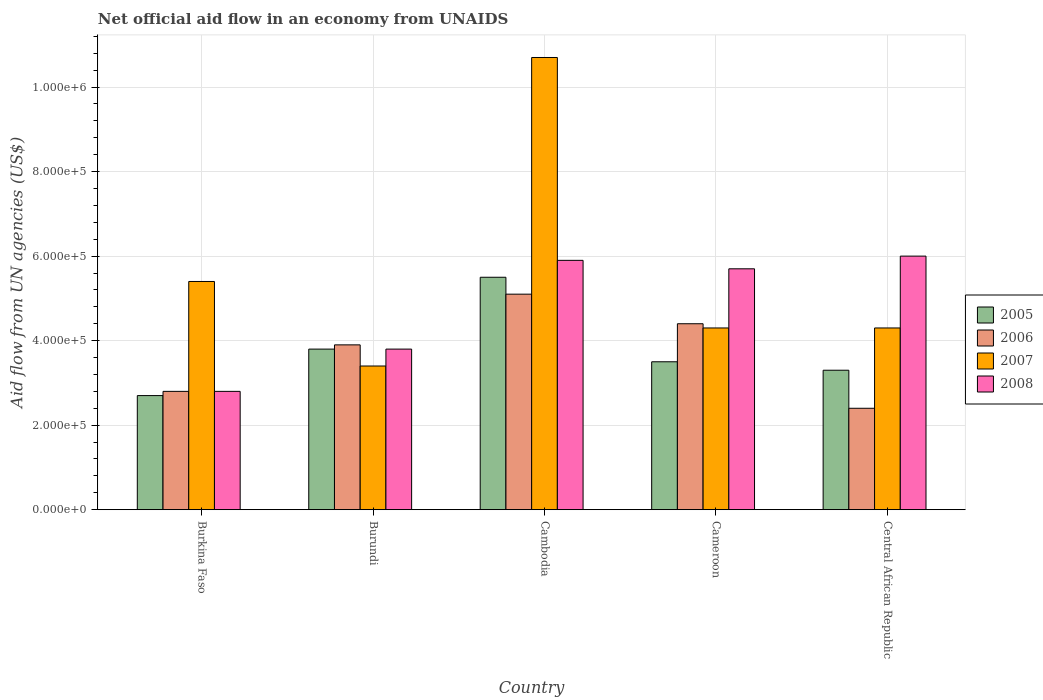How many different coloured bars are there?
Keep it short and to the point. 4. How many bars are there on the 1st tick from the left?
Offer a terse response. 4. What is the label of the 3rd group of bars from the left?
Offer a very short reply. Cambodia. In how many cases, is the number of bars for a given country not equal to the number of legend labels?
Your answer should be very brief. 0. What is the net official aid flow in 2008 in Cambodia?
Make the answer very short. 5.90e+05. Across all countries, what is the maximum net official aid flow in 2007?
Provide a succinct answer. 1.07e+06. Across all countries, what is the minimum net official aid flow in 2008?
Provide a short and direct response. 2.80e+05. In which country was the net official aid flow in 2005 maximum?
Offer a terse response. Cambodia. In which country was the net official aid flow in 2006 minimum?
Ensure brevity in your answer.  Central African Republic. What is the total net official aid flow in 2007 in the graph?
Provide a succinct answer. 2.81e+06. What is the difference between the net official aid flow in 2006 in Cameroon and the net official aid flow in 2005 in Cambodia?
Offer a terse response. -1.10e+05. What is the average net official aid flow in 2006 per country?
Provide a short and direct response. 3.72e+05. What is the ratio of the net official aid flow in 2008 in Cameroon to that in Central African Republic?
Keep it short and to the point. 0.95. What is the difference between the highest and the second highest net official aid flow in 2008?
Your answer should be very brief. 3.00e+04. Is the sum of the net official aid flow in 2005 in Cambodia and Cameroon greater than the maximum net official aid flow in 2008 across all countries?
Make the answer very short. Yes. Is it the case that in every country, the sum of the net official aid flow in 2007 and net official aid flow in 2005 is greater than the sum of net official aid flow in 2006 and net official aid flow in 2008?
Offer a terse response. Yes. What does the 4th bar from the right in Burkina Faso represents?
Your answer should be compact. 2005. Is it the case that in every country, the sum of the net official aid flow in 2008 and net official aid flow in 2006 is greater than the net official aid flow in 2007?
Provide a short and direct response. Yes. Are all the bars in the graph horizontal?
Ensure brevity in your answer.  No. Does the graph contain any zero values?
Offer a very short reply. No. Does the graph contain grids?
Provide a succinct answer. Yes. How many legend labels are there?
Keep it short and to the point. 4. How are the legend labels stacked?
Make the answer very short. Vertical. What is the title of the graph?
Your answer should be compact. Net official aid flow in an economy from UNAIDS. What is the label or title of the Y-axis?
Your answer should be compact. Aid flow from UN agencies (US$). What is the Aid flow from UN agencies (US$) in 2006 in Burkina Faso?
Give a very brief answer. 2.80e+05. What is the Aid flow from UN agencies (US$) of 2007 in Burkina Faso?
Your answer should be very brief. 5.40e+05. What is the Aid flow from UN agencies (US$) in 2008 in Burkina Faso?
Offer a terse response. 2.80e+05. What is the Aid flow from UN agencies (US$) of 2005 in Burundi?
Give a very brief answer. 3.80e+05. What is the Aid flow from UN agencies (US$) in 2007 in Burundi?
Your answer should be very brief. 3.40e+05. What is the Aid flow from UN agencies (US$) in 2006 in Cambodia?
Make the answer very short. 5.10e+05. What is the Aid flow from UN agencies (US$) in 2007 in Cambodia?
Provide a short and direct response. 1.07e+06. What is the Aid flow from UN agencies (US$) of 2008 in Cambodia?
Your answer should be very brief. 5.90e+05. What is the Aid flow from UN agencies (US$) of 2006 in Cameroon?
Provide a succinct answer. 4.40e+05. What is the Aid flow from UN agencies (US$) of 2007 in Cameroon?
Provide a short and direct response. 4.30e+05. What is the Aid flow from UN agencies (US$) of 2008 in Cameroon?
Your answer should be very brief. 5.70e+05. What is the Aid flow from UN agencies (US$) in 2006 in Central African Republic?
Your response must be concise. 2.40e+05. What is the Aid flow from UN agencies (US$) in 2007 in Central African Republic?
Your answer should be compact. 4.30e+05. Across all countries, what is the maximum Aid flow from UN agencies (US$) in 2006?
Provide a succinct answer. 5.10e+05. Across all countries, what is the maximum Aid flow from UN agencies (US$) in 2007?
Your answer should be very brief. 1.07e+06. Across all countries, what is the minimum Aid flow from UN agencies (US$) in 2005?
Your response must be concise. 2.70e+05. What is the total Aid flow from UN agencies (US$) of 2005 in the graph?
Your response must be concise. 1.88e+06. What is the total Aid flow from UN agencies (US$) in 2006 in the graph?
Ensure brevity in your answer.  1.86e+06. What is the total Aid flow from UN agencies (US$) in 2007 in the graph?
Provide a short and direct response. 2.81e+06. What is the total Aid flow from UN agencies (US$) in 2008 in the graph?
Ensure brevity in your answer.  2.42e+06. What is the difference between the Aid flow from UN agencies (US$) in 2005 in Burkina Faso and that in Burundi?
Offer a terse response. -1.10e+05. What is the difference between the Aid flow from UN agencies (US$) in 2007 in Burkina Faso and that in Burundi?
Your answer should be very brief. 2.00e+05. What is the difference between the Aid flow from UN agencies (US$) of 2008 in Burkina Faso and that in Burundi?
Your answer should be very brief. -1.00e+05. What is the difference between the Aid flow from UN agencies (US$) in 2005 in Burkina Faso and that in Cambodia?
Provide a succinct answer. -2.80e+05. What is the difference between the Aid flow from UN agencies (US$) in 2007 in Burkina Faso and that in Cambodia?
Offer a very short reply. -5.30e+05. What is the difference between the Aid flow from UN agencies (US$) in 2008 in Burkina Faso and that in Cambodia?
Your answer should be very brief. -3.10e+05. What is the difference between the Aid flow from UN agencies (US$) of 2005 in Burkina Faso and that in Cameroon?
Your answer should be compact. -8.00e+04. What is the difference between the Aid flow from UN agencies (US$) of 2006 in Burkina Faso and that in Cameroon?
Make the answer very short. -1.60e+05. What is the difference between the Aid flow from UN agencies (US$) of 2008 in Burkina Faso and that in Central African Republic?
Your answer should be very brief. -3.20e+05. What is the difference between the Aid flow from UN agencies (US$) in 2007 in Burundi and that in Cambodia?
Give a very brief answer. -7.30e+05. What is the difference between the Aid flow from UN agencies (US$) of 2008 in Burundi and that in Cambodia?
Provide a succinct answer. -2.10e+05. What is the difference between the Aid flow from UN agencies (US$) in 2006 in Burundi and that in Cameroon?
Offer a terse response. -5.00e+04. What is the difference between the Aid flow from UN agencies (US$) in 2007 in Burundi and that in Cameroon?
Your response must be concise. -9.00e+04. What is the difference between the Aid flow from UN agencies (US$) of 2008 in Burundi and that in Cameroon?
Make the answer very short. -1.90e+05. What is the difference between the Aid flow from UN agencies (US$) of 2005 in Burundi and that in Central African Republic?
Keep it short and to the point. 5.00e+04. What is the difference between the Aid flow from UN agencies (US$) of 2005 in Cambodia and that in Cameroon?
Your answer should be compact. 2.00e+05. What is the difference between the Aid flow from UN agencies (US$) in 2007 in Cambodia and that in Cameroon?
Ensure brevity in your answer.  6.40e+05. What is the difference between the Aid flow from UN agencies (US$) in 2008 in Cambodia and that in Cameroon?
Provide a short and direct response. 2.00e+04. What is the difference between the Aid flow from UN agencies (US$) in 2006 in Cambodia and that in Central African Republic?
Your answer should be very brief. 2.70e+05. What is the difference between the Aid flow from UN agencies (US$) of 2007 in Cambodia and that in Central African Republic?
Offer a very short reply. 6.40e+05. What is the difference between the Aid flow from UN agencies (US$) in 2008 in Cambodia and that in Central African Republic?
Make the answer very short. -10000. What is the difference between the Aid flow from UN agencies (US$) of 2005 in Burkina Faso and the Aid flow from UN agencies (US$) of 2006 in Burundi?
Offer a terse response. -1.20e+05. What is the difference between the Aid flow from UN agencies (US$) in 2005 in Burkina Faso and the Aid flow from UN agencies (US$) in 2007 in Burundi?
Ensure brevity in your answer.  -7.00e+04. What is the difference between the Aid flow from UN agencies (US$) in 2005 in Burkina Faso and the Aid flow from UN agencies (US$) in 2008 in Burundi?
Offer a very short reply. -1.10e+05. What is the difference between the Aid flow from UN agencies (US$) in 2006 in Burkina Faso and the Aid flow from UN agencies (US$) in 2007 in Burundi?
Your answer should be compact. -6.00e+04. What is the difference between the Aid flow from UN agencies (US$) in 2006 in Burkina Faso and the Aid flow from UN agencies (US$) in 2008 in Burundi?
Make the answer very short. -1.00e+05. What is the difference between the Aid flow from UN agencies (US$) in 2007 in Burkina Faso and the Aid flow from UN agencies (US$) in 2008 in Burundi?
Your answer should be compact. 1.60e+05. What is the difference between the Aid flow from UN agencies (US$) in 2005 in Burkina Faso and the Aid flow from UN agencies (US$) in 2007 in Cambodia?
Make the answer very short. -8.00e+05. What is the difference between the Aid flow from UN agencies (US$) of 2005 in Burkina Faso and the Aid flow from UN agencies (US$) of 2008 in Cambodia?
Your answer should be very brief. -3.20e+05. What is the difference between the Aid flow from UN agencies (US$) of 2006 in Burkina Faso and the Aid flow from UN agencies (US$) of 2007 in Cambodia?
Make the answer very short. -7.90e+05. What is the difference between the Aid flow from UN agencies (US$) in 2006 in Burkina Faso and the Aid flow from UN agencies (US$) in 2008 in Cambodia?
Make the answer very short. -3.10e+05. What is the difference between the Aid flow from UN agencies (US$) of 2005 in Burkina Faso and the Aid flow from UN agencies (US$) of 2008 in Cameroon?
Provide a succinct answer. -3.00e+05. What is the difference between the Aid flow from UN agencies (US$) in 2006 in Burkina Faso and the Aid flow from UN agencies (US$) in 2008 in Cameroon?
Your response must be concise. -2.90e+05. What is the difference between the Aid flow from UN agencies (US$) of 2005 in Burkina Faso and the Aid flow from UN agencies (US$) of 2006 in Central African Republic?
Provide a short and direct response. 3.00e+04. What is the difference between the Aid flow from UN agencies (US$) of 2005 in Burkina Faso and the Aid flow from UN agencies (US$) of 2007 in Central African Republic?
Offer a very short reply. -1.60e+05. What is the difference between the Aid flow from UN agencies (US$) of 2005 in Burkina Faso and the Aid flow from UN agencies (US$) of 2008 in Central African Republic?
Give a very brief answer. -3.30e+05. What is the difference between the Aid flow from UN agencies (US$) in 2006 in Burkina Faso and the Aid flow from UN agencies (US$) in 2007 in Central African Republic?
Offer a terse response. -1.50e+05. What is the difference between the Aid flow from UN agencies (US$) in 2006 in Burkina Faso and the Aid flow from UN agencies (US$) in 2008 in Central African Republic?
Offer a very short reply. -3.20e+05. What is the difference between the Aid flow from UN agencies (US$) of 2007 in Burkina Faso and the Aid flow from UN agencies (US$) of 2008 in Central African Republic?
Provide a succinct answer. -6.00e+04. What is the difference between the Aid flow from UN agencies (US$) in 2005 in Burundi and the Aid flow from UN agencies (US$) in 2007 in Cambodia?
Provide a succinct answer. -6.90e+05. What is the difference between the Aid flow from UN agencies (US$) of 2005 in Burundi and the Aid flow from UN agencies (US$) of 2008 in Cambodia?
Offer a very short reply. -2.10e+05. What is the difference between the Aid flow from UN agencies (US$) in 2006 in Burundi and the Aid flow from UN agencies (US$) in 2007 in Cambodia?
Provide a short and direct response. -6.80e+05. What is the difference between the Aid flow from UN agencies (US$) of 2005 in Burundi and the Aid flow from UN agencies (US$) of 2008 in Cameroon?
Offer a very short reply. -1.90e+05. What is the difference between the Aid flow from UN agencies (US$) in 2007 in Burundi and the Aid flow from UN agencies (US$) in 2008 in Cameroon?
Give a very brief answer. -2.30e+05. What is the difference between the Aid flow from UN agencies (US$) in 2005 in Burundi and the Aid flow from UN agencies (US$) in 2006 in Central African Republic?
Ensure brevity in your answer.  1.40e+05. What is the difference between the Aid flow from UN agencies (US$) in 2005 in Burundi and the Aid flow from UN agencies (US$) in 2008 in Central African Republic?
Provide a succinct answer. -2.20e+05. What is the difference between the Aid flow from UN agencies (US$) in 2006 in Burundi and the Aid flow from UN agencies (US$) in 2008 in Central African Republic?
Keep it short and to the point. -2.10e+05. What is the difference between the Aid flow from UN agencies (US$) of 2005 in Cambodia and the Aid flow from UN agencies (US$) of 2008 in Cameroon?
Offer a terse response. -2.00e+04. What is the difference between the Aid flow from UN agencies (US$) in 2006 in Cambodia and the Aid flow from UN agencies (US$) in 2007 in Cameroon?
Offer a terse response. 8.00e+04. What is the difference between the Aid flow from UN agencies (US$) in 2007 in Cambodia and the Aid flow from UN agencies (US$) in 2008 in Cameroon?
Keep it short and to the point. 5.00e+05. What is the difference between the Aid flow from UN agencies (US$) of 2005 in Cambodia and the Aid flow from UN agencies (US$) of 2006 in Central African Republic?
Your answer should be compact. 3.10e+05. What is the difference between the Aid flow from UN agencies (US$) in 2006 in Cambodia and the Aid flow from UN agencies (US$) in 2007 in Central African Republic?
Make the answer very short. 8.00e+04. What is the difference between the Aid flow from UN agencies (US$) of 2005 in Cameroon and the Aid flow from UN agencies (US$) of 2006 in Central African Republic?
Give a very brief answer. 1.10e+05. What is the difference between the Aid flow from UN agencies (US$) in 2005 in Cameroon and the Aid flow from UN agencies (US$) in 2008 in Central African Republic?
Give a very brief answer. -2.50e+05. What is the average Aid flow from UN agencies (US$) of 2005 per country?
Make the answer very short. 3.76e+05. What is the average Aid flow from UN agencies (US$) of 2006 per country?
Offer a very short reply. 3.72e+05. What is the average Aid flow from UN agencies (US$) of 2007 per country?
Ensure brevity in your answer.  5.62e+05. What is the average Aid flow from UN agencies (US$) of 2008 per country?
Provide a short and direct response. 4.84e+05. What is the difference between the Aid flow from UN agencies (US$) in 2005 and Aid flow from UN agencies (US$) in 2006 in Burkina Faso?
Provide a succinct answer. -10000. What is the difference between the Aid flow from UN agencies (US$) in 2005 and Aid flow from UN agencies (US$) in 2007 in Burkina Faso?
Offer a terse response. -2.70e+05. What is the difference between the Aid flow from UN agencies (US$) in 2005 and Aid flow from UN agencies (US$) in 2008 in Burkina Faso?
Offer a terse response. -10000. What is the difference between the Aid flow from UN agencies (US$) in 2005 and Aid flow from UN agencies (US$) in 2006 in Burundi?
Ensure brevity in your answer.  -10000. What is the difference between the Aid flow from UN agencies (US$) of 2006 and Aid flow from UN agencies (US$) of 2007 in Burundi?
Your answer should be very brief. 5.00e+04. What is the difference between the Aid flow from UN agencies (US$) in 2006 and Aid flow from UN agencies (US$) in 2008 in Burundi?
Give a very brief answer. 10000. What is the difference between the Aid flow from UN agencies (US$) of 2005 and Aid flow from UN agencies (US$) of 2006 in Cambodia?
Provide a short and direct response. 4.00e+04. What is the difference between the Aid flow from UN agencies (US$) in 2005 and Aid flow from UN agencies (US$) in 2007 in Cambodia?
Make the answer very short. -5.20e+05. What is the difference between the Aid flow from UN agencies (US$) of 2006 and Aid flow from UN agencies (US$) of 2007 in Cambodia?
Make the answer very short. -5.60e+05. What is the difference between the Aid flow from UN agencies (US$) of 2006 and Aid flow from UN agencies (US$) of 2008 in Cambodia?
Your answer should be very brief. -8.00e+04. What is the difference between the Aid flow from UN agencies (US$) of 2005 and Aid flow from UN agencies (US$) of 2007 in Cameroon?
Keep it short and to the point. -8.00e+04. What is the difference between the Aid flow from UN agencies (US$) of 2006 and Aid flow from UN agencies (US$) of 2008 in Cameroon?
Provide a succinct answer. -1.30e+05. What is the difference between the Aid flow from UN agencies (US$) in 2007 and Aid flow from UN agencies (US$) in 2008 in Cameroon?
Your response must be concise. -1.40e+05. What is the difference between the Aid flow from UN agencies (US$) in 2006 and Aid flow from UN agencies (US$) in 2008 in Central African Republic?
Keep it short and to the point. -3.60e+05. What is the difference between the Aid flow from UN agencies (US$) in 2007 and Aid flow from UN agencies (US$) in 2008 in Central African Republic?
Make the answer very short. -1.70e+05. What is the ratio of the Aid flow from UN agencies (US$) of 2005 in Burkina Faso to that in Burundi?
Provide a succinct answer. 0.71. What is the ratio of the Aid flow from UN agencies (US$) in 2006 in Burkina Faso to that in Burundi?
Make the answer very short. 0.72. What is the ratio of the Aid flow from UN agencies (US$) of 2007 in Burkina Faso to that in Burundi?
Make the answer very short. 1.59. What is the ratio of the Aid flow from UN agencies (US$) in 2008 in Burkina Faso to that in Burundi?
Offer a terse response. 0.74. What is the ratio of the Aid flow from UN agencies (US$) of 2005 in Burkina Faso to that in Cambodia?
Ensure brevity in your answer.  0.49. What is the ratio of the Aid flow from UN agencies (US$) in 2006 in Burkina Faso to that in Cambodia?
Keep it short and to the point. 0.55. What is the ratio of the Aid flow from UN agencies (US$) in 2007 in Burkina Faso to that in Cambodia?
Ensure brevity in your answer.  0.5. What is the ratio of the Aid flow from UN agencies (US$) of 2008 in Burkina Faso to that in Cambodia?
Ensure brevity in your answer.  0.47. What is the ratio of the Aid flow from UN agencies (US$) of 2005 in Burkina Faso to that in Cameroon?
Keep it short and to the point. 0.77. What is the ratio of the Aid flow from UN agencies (US$) of 2006 in Burkina Faso to that in Cameroon?
Provide a short and direct response. 0.64. What is the ratio of the Aid flow from UN agencies (US$) in 2007 in Burkina Faso to that in Cameroon?
Offer a very short reply. 1.26. What is the ratio of the Aid flow from UN agencies (US$) of 2008 in Burkina Faso to that in Cameroon?
Ensure brevity in your answer.  0.49. What is the ratio of the Aid flow from UN agencies (US$) in 2005 in Burkina Faso to that in Central African Republic?
Your answer should be compact. 0.82. What is the ratio of the Aid flow from UN agencies (US$) of 2007 in Burkina Faso to that in Central African Republic?
Your answer should be very brief. 1.26. What is the ratio of the Aid flow from UN agencies (US$) in 2008 in Burkina Faso to that in Central African Republic?
Ensure brevity in your answer.  0.47. What is the ratio of the Aid flow from UN agencies (US$) of 2005 in Burundi to that in Cambodia?
Ensure brevity in your answer.  0.69. What is the ratio of the Aid flow from UN agencies (US$) in 2006 in Burundi to that in Cambodia?
Offer a very short reply. 0.76. What is the ratio of the Aid flow from UN agencies (US$) of 2007 in Burundi to that in Cambodia?
Make the answer very short. 0.32. What is the ratio of the Aid flow from UN agencies (US$) of 2008 in Burundi to that in Cambodia?
Offer a very short reply. 0.64. What is the ratio of the Aid flow from UN agencies (US$) in 2005 in Burundi to that in Cameroon?
Offer a terse response. 1.09. What is the ratio of the Aid flow from UN agencies (US$) of 2006 in Burundi to that in Cameroon?
Offer a very short reply. 0.89. What is the ratio of the Aid flow from UN agencies (US$) of 2007 in Burundi to that in Cameroon?
Your response must be concise. 0.79. What is the ratio of the Aid flow from UN agencies (US$) of 2005 in Burundi to that in Central African Republic?
Make the answer very short. 1.15. What is the ratio of the Aid flow from UN agencies (US$) of 2006 in Burundi to that in Central African Republic?
Offer a terse response. 1.62. What is the ratio of the Aid flow from UN agencies (US$) in 2007 in Burundi to that in Central African Republic?
Offer a terse response. 0.79. What is the ratio of the Aid flow from UN agencies (US$) of 2008 in Burundi to that in Central African Republic?
Your answer should be compact. 0.63. What is the ratio of the Aid flow from UN agencies (US$) of 2005 in Cambodia to that in Cameroon?
Provide a succinct answer. 1.57. What is the ratio of the Aid flow from UN agencies (US$) of 2006 in Cambodia to that in Cameroon?
Provide a succinct answer. 1.16. What is the ratio of the Aid flow from UN agencies (US$) in 2007 in Cambodia to that in Cameroon?
Provide a succinct answer. 2.49. What is the ratio of the Aid flow from UN agencies (US$) in 2008 in Cambodia to that in Cameroon?
Provide a short and direct response. 1.04. What is the ratio of the Aid flow from UN agencies (US$) in 2005 in Cambodia to that in Central African Republic?
Offer a very short reply. 1.67. What is the ratio of the Aid flow from UN agencies (US$) in 2006 in Cambodia to that in Central African Republic?
Offer a terse response. 2.12. What is the ratio of the Aid flow from UN agencies (US$) of 2007 in Cambodia to that in Central African Republic?
Offer a very short reply. 2.49. What is the ratio of the Aid flow from UN agencies (US$) of 2008 in Cambodia to that in Central African Republic?
Make the answer very short. 0.98. What is the ratio of the Aid flow from UN agencies (US$) in 2005 in Cameroon to that in Central African Republic?
Your answer should be compact. 1.06. What is the ratio of the Aid flow from UN agencies (US$) in 2006 in Cameroon to that in Central African Republic?
Your response must be concise. 1.83. What is the ratio of the Aid flow from UN agencies (US$) of 2008 in Cameroon to that in Central African Republic?
Offer a very short reply. 0.95. What is the difference between the highest and the second highest Aid flow from UN agencies (US$) of 2006?
Make the answer very short. 7.00e+04. What is the difference between the highest and the second highest Aid flow from UN agencies (US$) of 2007?
Your answer should be compact. 5.30e+05. What is the difference between the highest and the lowest Aid flow from UN agencies (US$) of 2006?
Provide a succinct answer. 2.70e+05. What is the difference between the highest and the lowest Aid flow from UN agencies (US$) of 2007?
Your response must be concise. 7.30e+05. 